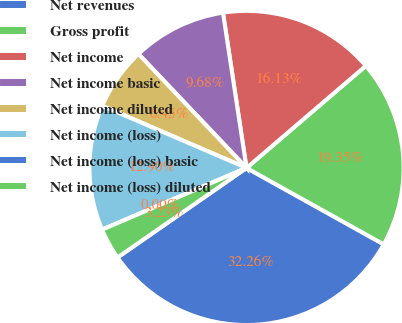Convert chart to OTSL. <chart><loc_0><loc_0><loc_500><loc_500><pie_chart><fcel>Net revenues<fcel>Gross profit<fcel>Net income<fcel>Net income basic<fcel>Net income diluted<fcel>Net income (loss)<fcel>Net income (loss) basic<fcel>Net income (loss) diluted<nl><fcel>32.26%<fcel>19.35%<fcel>16.13%<fcel>9.68%<fcel>6.45%<fcel>12.9%<fcel>0.0%<fcel>3.23%<nl></chart> 